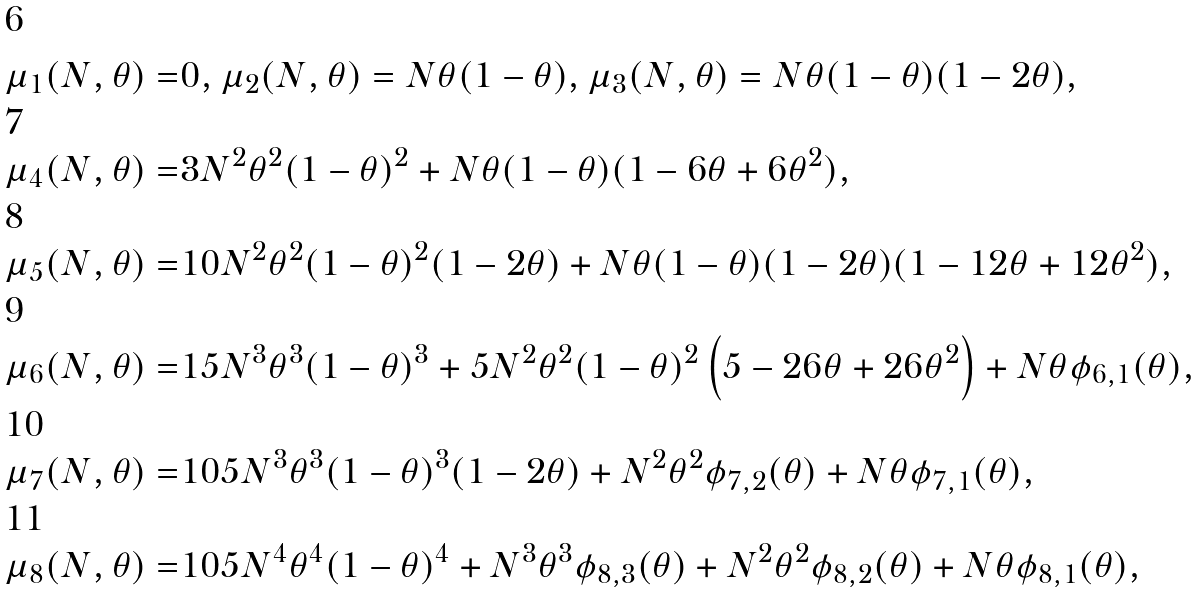Convert formula to latex. <formula><loc_0><loc_0><loc_500><loc_500>\mu _ { 1 } ( N , \theta ) = & 0 , \mu _ { 2 } ( N , \theta ) = N \theta ( 1 - \theta ) , \mu _ { 3 } ( N , \theta ) = N \theta ( 1 - \theta ) ( 1 - 2 \theta ) , \\ \mu _ { 4 } ( N , \theta ) = & 3 N ^ { 2 } \theta ^ { 2 } ( 1 - \theta ) ^ { 2 } + N \theta ( 1 - \theta ) ( 1 - 6 \theta + 6 \theta ^ { 2 } ) , \\ \mu _ { 5 } ( N , \theta ) = & 1 0 N ^ { 2 } \theta ^ { 2 } ( 1 - \theta ) ^ { 2 } ( 1 - 2 \theta ) + N \theta ( 1 - \theta ) ( 1 - 2 \theta ) ( 1 - 1 2 \theta + 1 2 \theta ^ { 2 } ) , \\ \mu _ { 6 } ( N , \theta ) = & 1 5 N ^ { 3 } \theta ^ { 3 } ( 1 - \theta ) ^ { 3 } + 5 N ^ { 2 } \theta ^ { 2 } ( 1 - \theta ) ^ { 2 } \left ( 5 - 2 6 \theta + 2 6 \theta ^ { 2 } \right ) + N \theta \phi _ { 6 , 1 } ( \theta ) , \\ \mu _ { 7 } ( N , \theta ) = & 1 0 5 N ^ { 3 } \theta ^ { 3 } ( 1 - \theta ) ^ { 3 } ( 1 - 2 \theta ) + N ^ { 2 } \theta ^ { 2 } \phi _ { 7 , 2 } ( \theta ) + N \theta \phi _ { 7 , 1 } ( \theta ) , \\ \mu _ { 8 } ( N , \theta ) = & 1 0 5 N ^ { 4 } \theta ^ { 4 } ( 1 - \theta ) ^ { 4 } + N ^ { 3 } \theta ^ { 3 } \phi _ { 8 , 3 } ( \theta ) + N ^ { 2 } \theta ^ { 2 } \phi _ { 8 , 2 } ( \theta ) + N \theta \phi _ { 8 , 1 } ( \theta ) ,</formula> 